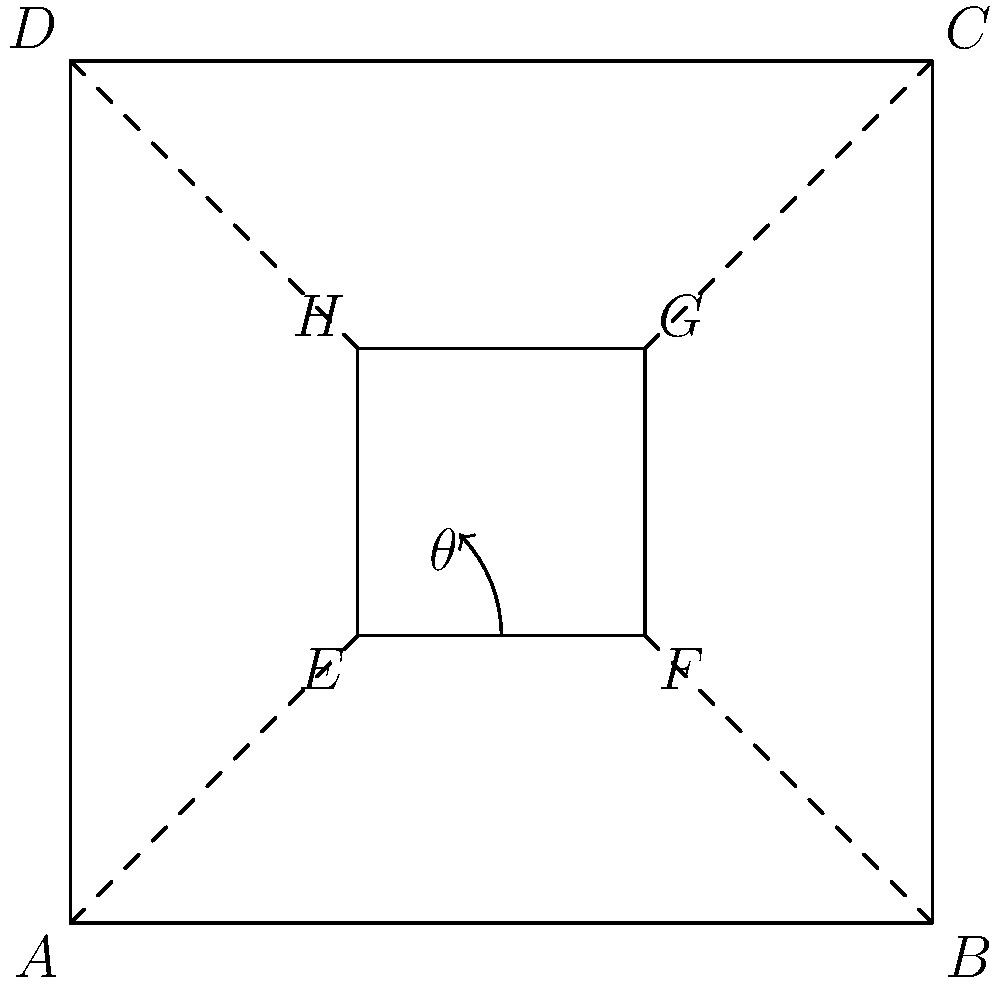In the circuit diagram above, ABCD represents the outer casing of an electronic device, while EFGH represents an internal component. The angle $\theta$ is formed by the dashed line AE and the side EF of the internal component. Given that ABCD is a square with side length 3 units and EFGH is a square with side length 1 unit, calculate the value of $\theta$ in degrees. To solve this problem, we'll follow these steps:

1) First, let's identify the triangle formed by AE and EF. This is a right-angled triangle.

2) We need to find the tangent of angle $\theta$. In a right-angled triangle, $\tan(\theta) = \frac{\text{opposite}}{\text{adjacent}}$.

3) The opposite side is EF, which is 1 unit long (as EFGH is a square with side length 1).

4) The adjacent side is AE. To find its length:
   - The side length of ABCD is 3 units
   - E is 1 unit from both A and D
   - So AE is $\sqrt{1^2 + 1^2} = \sqrt{2}$ units long

5) Now we can calculate $\tan(\theta)$:

   $\tan(\theta) = \frac{1}{\sqrt{2}}$

6) To find $\theta$, we need to take the inverse tangent (arctan or $\tan^{-1}$):

   $\theta = \tan^{-1}(\frac{1}{\sqrt{2}})$

7) Using a calculator or knowing that this is a common angle:

   $\theta = 45°$

Therefore, the angle $\theta$ is 45°.
Answer: 45° 